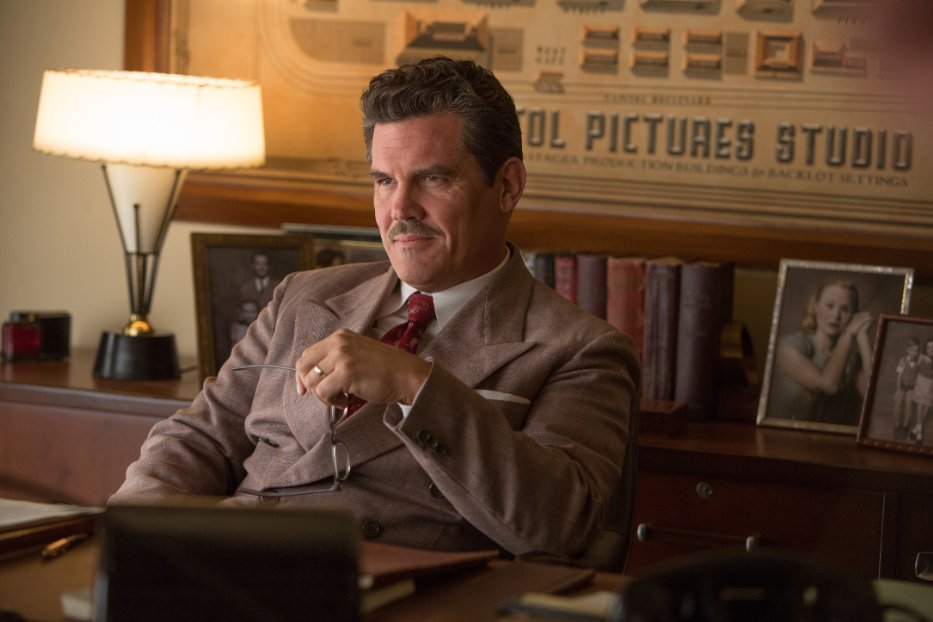What might be the significance of the objects in Mannix's office? The objects in Mannix’s office, such as the lamp, the framed pictures, and the cigar, likely serve to underline his character’s personality and the era in which he operates. The framed pictures might be of loved ones or important moments from his career, grounding him in a personal narrative. The vintage style of the office suggests a setting in an earlier period, possibly the 1950s, which aligns with the historical backdrop of the film 'Hail, Caesar!'. The cigar hints at his character's habits and personality - typically someone who is thoughtful, assertive, and perhaps dealing with significant stress or decisions. 